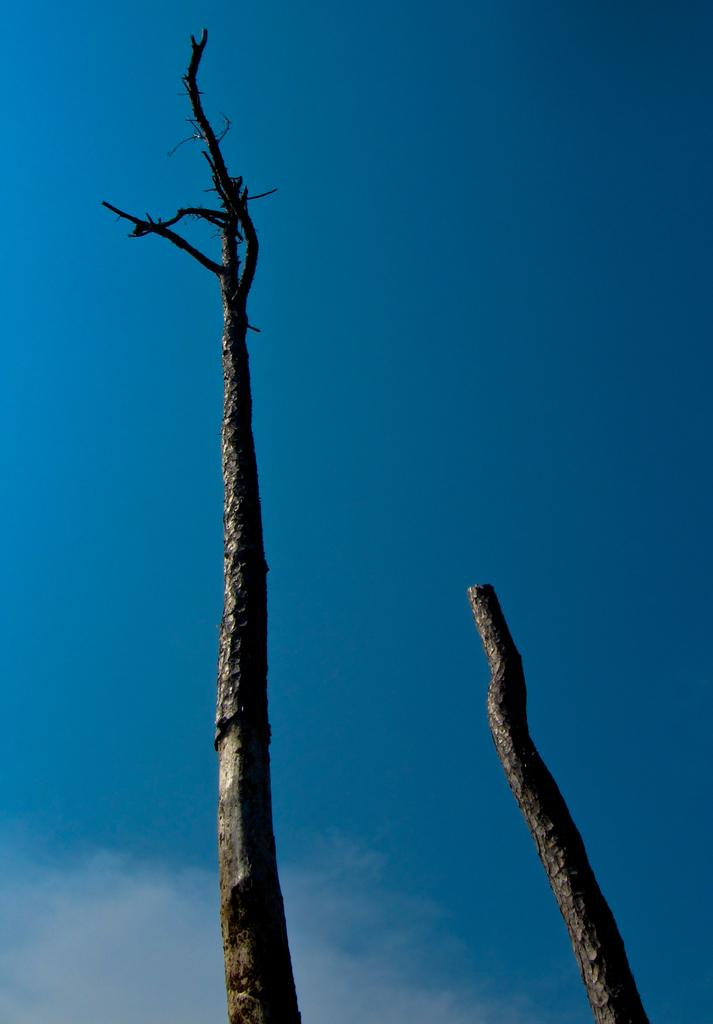What objects can be seen in the image? There are two dried tree branches in the image. What is visible in the background of the image? There is a sky visible in the image. What can be observed in the sky? Clouds are present in the sky. What type of knot is tied on the end of one of the tree branches? There is no knot tied on the end of any of the tree branches in the image. What kind of dinner is being prepared in the image? There is no dinner preparation or any indication of food in the image. 